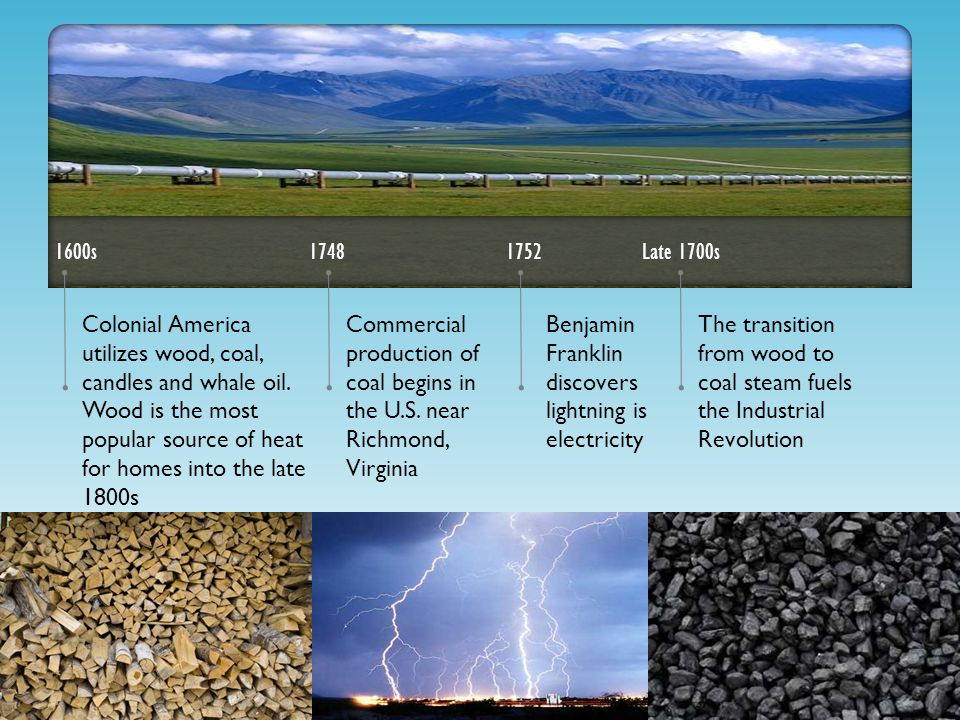Imagine a world in which coal was never discovered. How might human civilization have evolved technologically and socially? In a world where coal was never discovered, human civilization might have taken a different technological and social trajectory. The absence of coal would have likely stymied the Industrial Revolution or forced it to rely on alternative sources of energy, such as water power, wind power, or perhaps an accelerated discovery and usage of oil and natural gas. Technological advancements might have been slower without the high energy output coal provided. Society could be more agrarian, with smaller-scale industrial enterprises limited to areas with abundant water or wind resources. Environmental consequences might also look very different; while the severe pollution caused by coal would be absent, other environmental strains, like deforestation or limited water resources, might pose different challenges. The urbanization trends might also differ, with more people potentially living in rural settings or in cities designed around sustainable practices established centuries earlier. 